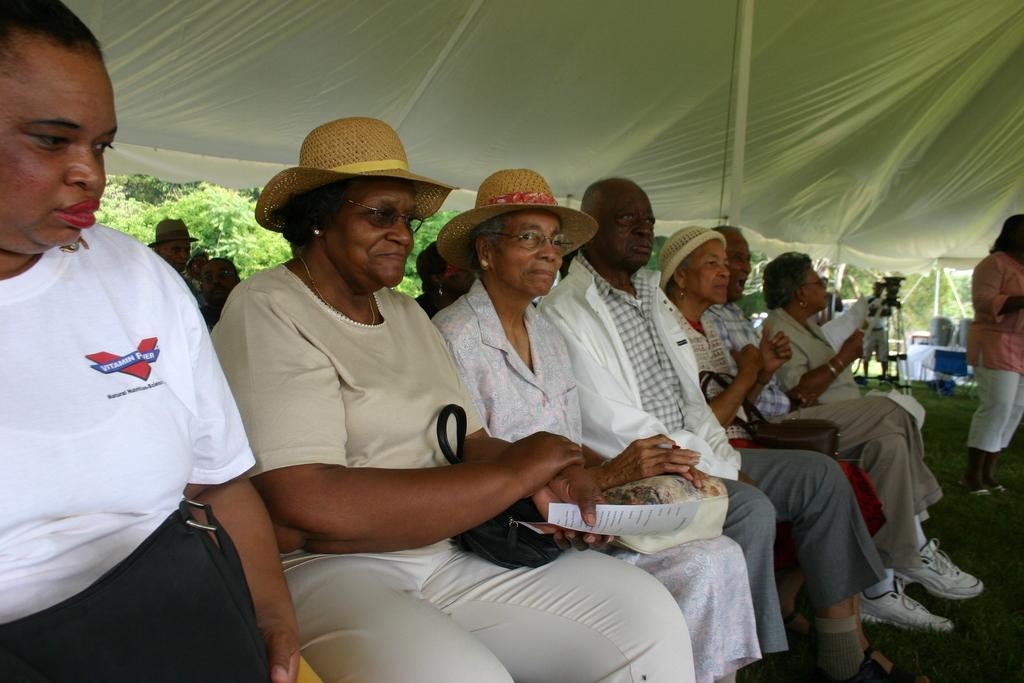Can you describe this image briefly? This picture seems to be clicked under the tent. On the left we can see the group of people seems to be sitting on the chairs and we can see the sling bags and the text on the papers. On the right there is a person standing on the ground. At the top we can see the roof of the tent. In the background we can see the plants and trees and we can see the metal rods, a person standing on the ground and many other objects and we can see the green grass. 